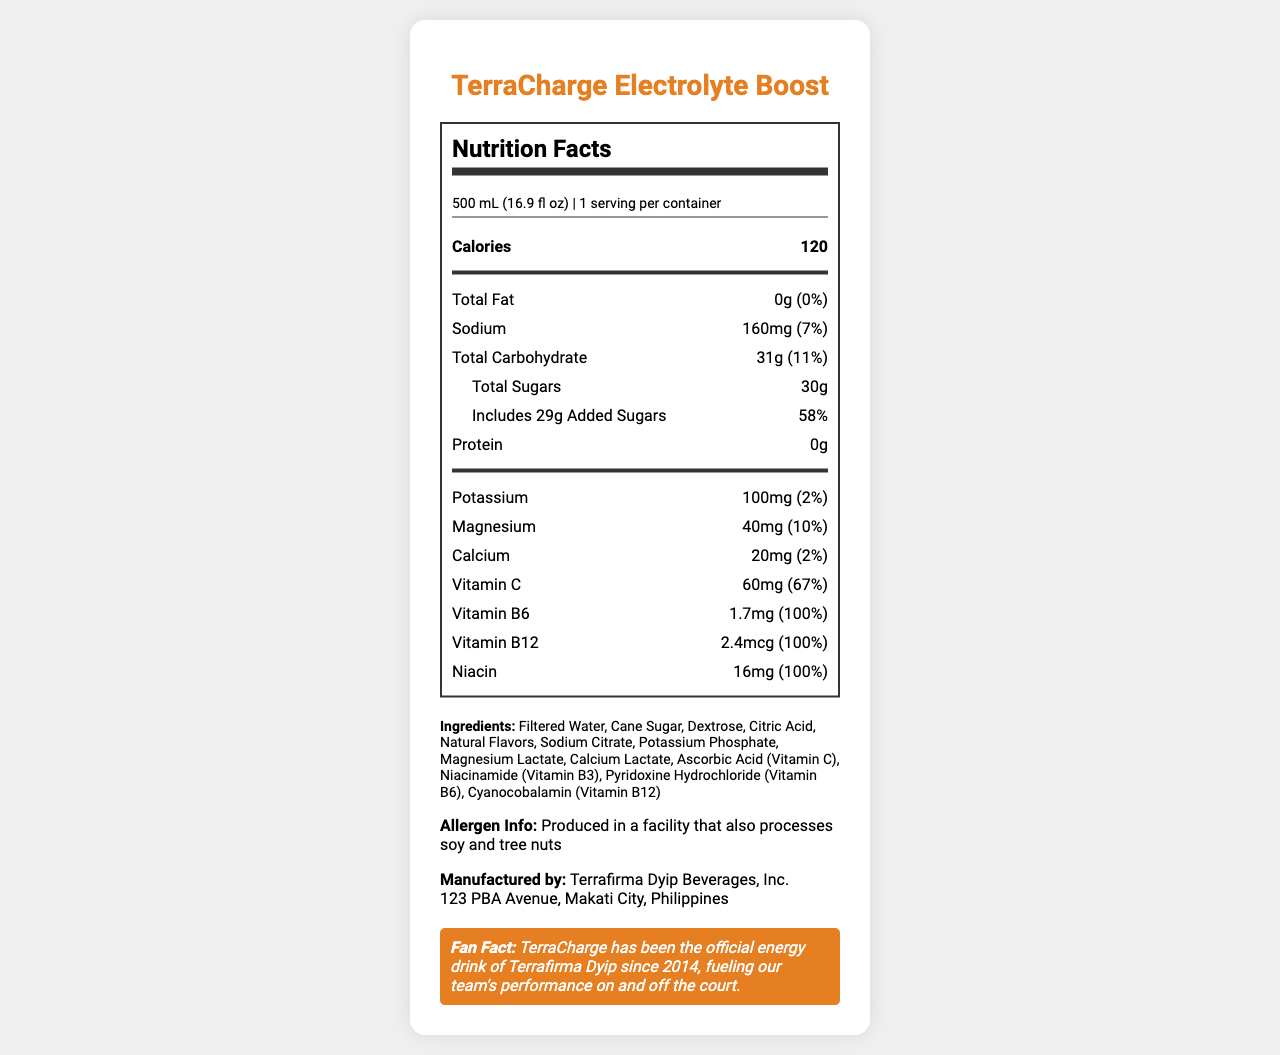what is the product name? The product name is prominently displayed at the top of the document.
Answer: TerraCharge Electrolyte Boost what is the serving size for TerraCharge Electrolyte Boost? The serving size is mentioned under the nutrition facts header.
Answer: 500 mL (16.9 fl oz) how many calories are in one serving? The number of calories in one serving is listed in a bold format in the nutrition facts section.
Answer: 120 what is the percentage of Daily Value for vitamin C? The percentage of Daily Value for vitamin C is found in the section listing various nutrients.
Answer: 67% how much added sugar does the drink contain? The amount of added sugar is listed under the total sugars section.
Answer: 29g how much sodium is in TerraCharge Electrolyte Boost? The amount of sodium can be found in the nutrition facts section.
Answer: 160mg which vitamins are present at 100% Daily Value? A. Vitamin C and Vitamin B6 B. Vitamin B6 and Niacin C. Vitamin B6, Vitamin B12 and Niacin D. None of the above The vitamins B6, B12, and Niacin all have a Daily Value of 100%.
Answer: C what is the total carbohydrate content per serving? A. 11g B. 27g C. 31g D. 47g The total carbohydrate content per serving is listed as 31g in the nutrition facts section.
Answer: C is there any protein in TerraCharge Electrolyte Boost? The document specifies a protein content of 0g.
Answer: No does the product contain any fat? The total fat content is marked as 0g, which means the product contains no fat.
Answer: No why is TerraCharge Electrolyte Boost beneficial for athletes? The drink includes beneficial nutrients like potassium, magnesium, calcium, and several vitamins that can help athletes stay hydrated and energized.
Answer: It contains essential electrolytes, vitamins, and added sugars to fuel performance. who manufactures TerraCharge Electrolyte Boost? The manufacturer information is provided at the bottom of the document.
Answer: Terrafirma Dyip Beverages, Inc. provide a summary of this document. The document is a comprehensive nutrition label which includes essential information about the energy drink's nutritional content, ingredients, and other relevant details for consumers.
Answer: The document provides detailed nutrition facts for TerraCharge Electrolyte Boost, including serving size, calorie count, and nutrient content (vitamins, minerals, etc.). It lists ingredients, allergen information, and manufacturer details, along with a 'fan fact' related to the Terrafirma Dyip basketball team. how much potassium does the product contain? The amount of potassium is listed under the nutrition facts.
Answer: 100mg what is the address of the manufacturer? The manufacturer's address is provided at the bottom along with the manufacturer information.
Answer: 123 PBA Avenue, Makati City, Philippines what year did TerraCharge become the official energy drink of the Terrafirma Dyip? The fan fact section reveals that TerraCharge has been the official energy drink of the Terrafirma Dyip since 2014.
Answer: 2014 who is the target audience for this product? The document does not provide specific information about the target audience for this product.
Answer: Cannot be determined 